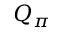Convert formula to latex. <formula><loc_0><loc_0><loc_500><loc_500>Q _ { \pi }</formula> 